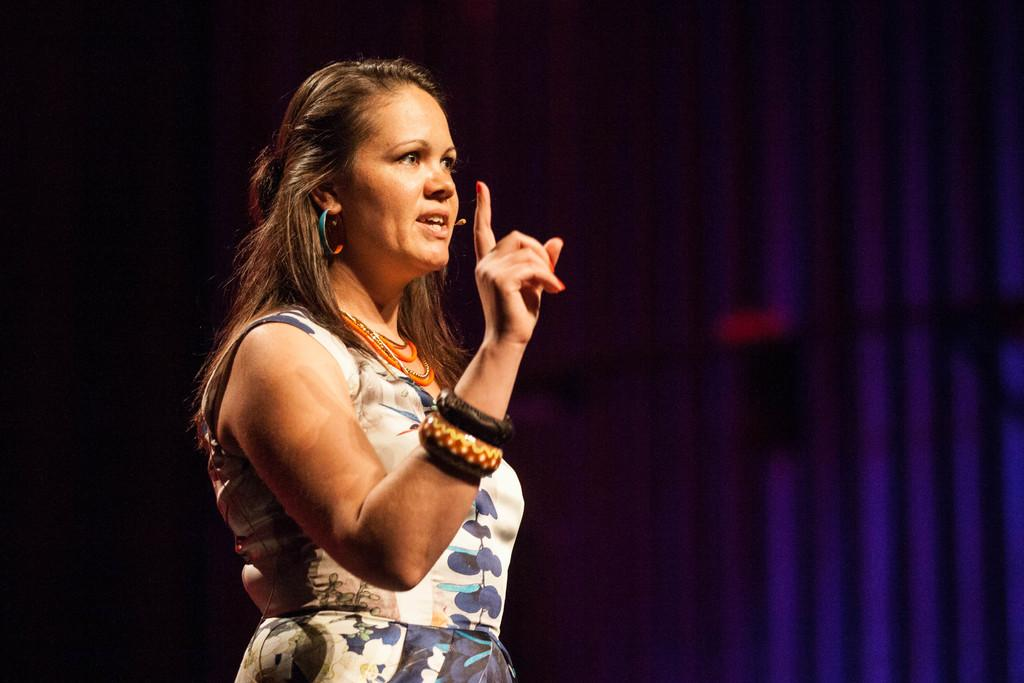Who is the main subject in the image? There is a woman in the image. What is the woman wearing? The woman is wearing a white dress. What is the woman doing in the image? The woman is talking. Are there any accessories visible on the woman? Yes, the woman is wearing bangles. What can be seen in the background of the image? The background of the image is dark. What color is visible on the right side of the image? There is a blue color visible on the right side of the image. Is there a maid cleaning the room in the image? There is no maid or indication of cleaning in the image; it features a woman talking while wearing a white dress, bangles, and a dark background with a blue color on the right side. What type of ornament is hanging from the ceiling in the image? There is no ornament hanging from the ceiling in the image; it only features a woman, her clothing, and accessories, as well as the background and color details. 